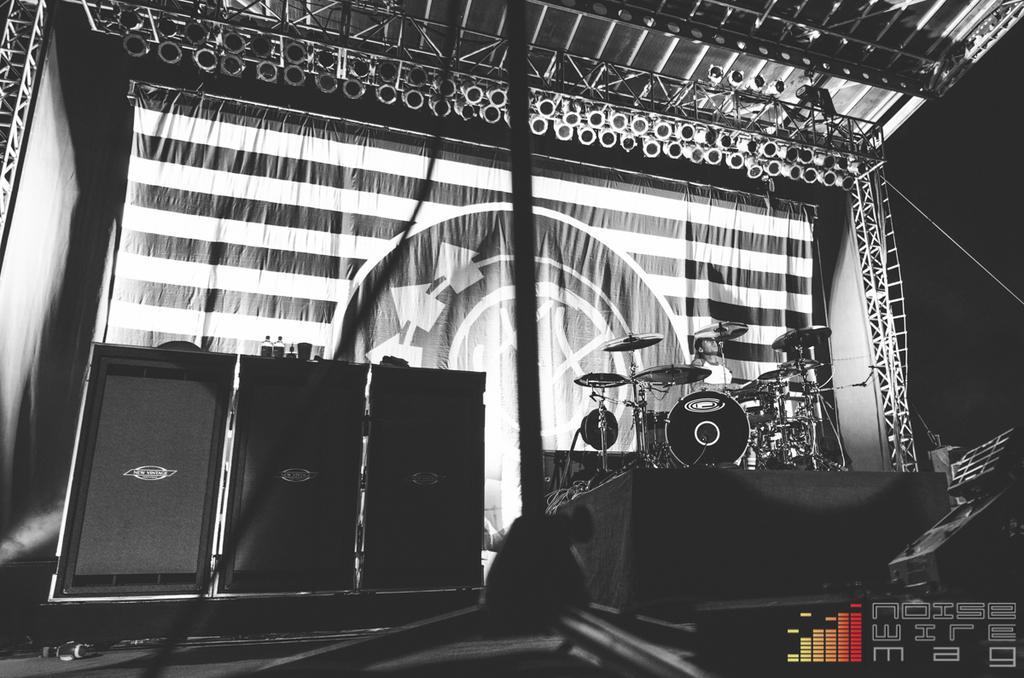Could you give a brief overview of what you see in this image? In this image, there are speakers, stage, stand and few objects. On the right side of the image, we can see a person playing a musical instrument. In the background, there are rods, banner, lights, ropes and dark view. In the bottom right corner, there is a watermark in the image. 